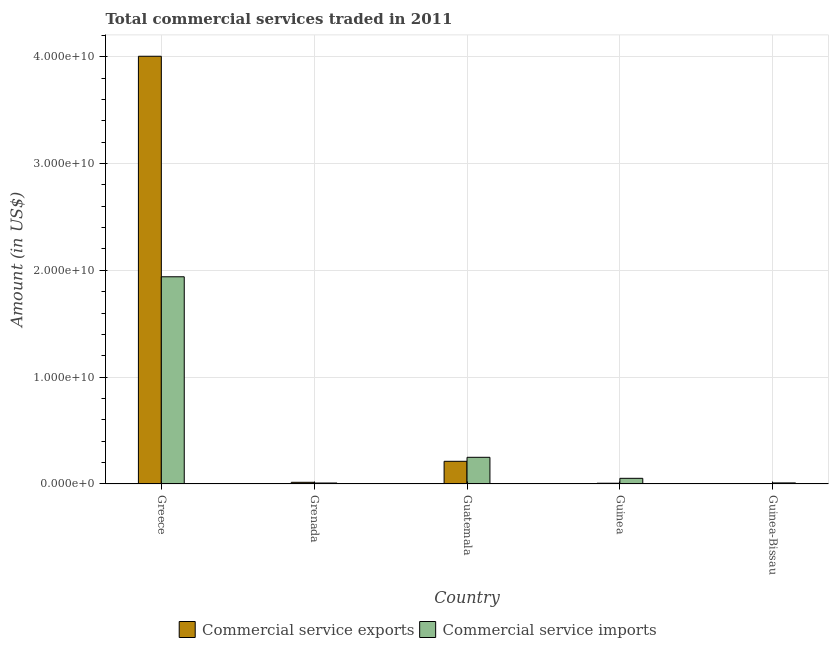Are the number of bars on each tick of the X-axis equal?
Give a very brief answer. Yes. How many bars are there on the 5th tick from the left?
Your answer should be compact. 2. What is the label of the 5th group of bars from the left?
Give a very brief answer. Guinea-Bissau. What is the amount of commercial service exports in Guinea?
Your response must be concise. 7.06e+07. Across all countries, what is the maximum amount of commercial service imports?
Provide a short and direct response. 1.94e+1. Across all countries, what is the minimum amount of commercial service exports?
Provide a short and direct response. 4.35e+07. In which country was the amount of commercial service exports minimum?
Give a very brief answer. Guinea-Bissau. What is the total amount of commercial service imports in the graph?
Offer a terse response. 2.26e+1. What is the difference between the amount of commercial service exports in Guatemala and that in Guinea-Bissau?
Provide a succinct answer. 2.08e+09. What is the difference between the amount of commercial service imports in Guinea-Bissau and the amount of commercial service exports in Greece?
Keep it short and to the point. -3.99e+1. What is the average amount of commercial service imports per country?
Offer a very short reply. 4.52e+09. What is the difference between the amount of commercial service exports and amount of commercial service imports in Guinea-Bissau?
Give a very brief answer. -5.61e+07. What is the ratio of the amount of commercial service imports in Greece to that in Grenada?
Offer a very short reply. 213.61. What is the difference between the highest and the second highest amount of commercial service imports?
Give a very brief answer. 1.69e+1. What is the difference between the highest and the lowest amount of commercial service imports?
Provide a succinct answer. 1.93e+1. What does the 1st bar from the left in Guinea represents?
Offer a terse response. Commercial service exports. What does the 2nd bar from the right in Guatemala represents?
Keep it short and to the point. Commercial service exports. How many countries are there in the graph?
Make the answer very short. 5. Does the graph contain grids?
Provide a succinct answer. Yes. How are the legend labels stacked?
Your answer should be compact. Horizontal. What is the title of the graph?
Your answer should be compact. Total commercial services traded in 2011. What is the label or title of the X-axis?
Offer a terse response. Country. What is the Amount (in US$) of Commercial service exports in Greece?
Your answer should be compact. 4.00e+1. What is the Amount (in US$) of Commercial service imports in Greece?
Offer a terse response. 1.94e+1. What is the Amount (in US$) in Commercial service exports in Grenada?
Provide a succinct answer. 1.57e+08. What is the Amount (in US$) of Commercial service imports in Grenada?
Your answer should be compact. 9.08e+07. What is the Amount (in US$) in Commercial service exports in Guatemala?
Ensure brevity in your answer.  2.12e+09. What is the Amount (in US$) of Commercial service imports in Guatemala?
Provide a short and direct response. 2.50e+09. What is the Amount (in US$) of Commercial service exports in Guinea?
Provide a succinct answer. 7.06e+07. What is the Amount (in US$) in Commercial service imports in Guinea?
Your response must be concise. 5.30e+08. What is the Amount (in US$) in Commercial service exports in Guinea-Bissau?
Make the answer very short. 4.35e+07. What is the Amount (in US$) in Commercial service imports in Guinea-Bissau?
Provide a short and direct response. 9.96e+07. Across all countries, what is the maximum Amount (in US$) in Commercial service exports?
Provide a succinct answer. 4.00e+1. Across all countries, what is the maximum Amount (in US$) in Commercial service imports?
Your response must be concise. 1.94e+1. Across all countries, what is the minimum Amount (in US$) of Commercial service exports?
Provide a short and direct response. 4.35e+07. Across all countries, what is the minimum Amount (in US$) of Commercial service imports?
Your response must be concise. 9.08e+07. What is the total Amount (in US$) in Commercial service exports in the graph?
Your answer should be very brief. 4.24e+1. What is the total Amount (in US$) in Commercial service imports in the graph?
Provide a short and direct response. 2.26e+1. What is the difference between the Amount (in US$) of Commercial service exports in Greece and that in Grenada?
Provide a short and direct response. 3.99e+1. What is the difference between the Amount (in US$) of Commercial service imports in Greece and that in Grenada?
Provide a succinct answer. 1.93e+1. What is the difference between the Amount (in US$) in Commercial service exports in Greece and that in Guatemala?
Make the answer very short. 3.79e+1. What is the difference between the Amount (in US$) in Commercial service imports in Greece and that in Guatemala?
Offer a terse response. 1.69e+1. What is the difference between the Amount (in US$) of Commercial service exports in Greece and that in Guinea?
Your response must be concise. 4.00e+1. What is the difference between the Amount (in US$) in Commercial service imports in Greece and that in Guinea?
Ensure brevity in your answer.  1.89e+1. What is the difference between the Amount (in US$) in Commercial service exports in Greece and that in Guinea-Bissau?
Your answer should be very brief. 4.00e+1. What is the difference between the Amount (in US$) in Commercial service imports in Greece and that in Guinea-Bissau?
Your answer should be compact. 1.93e+1. What is the difference between the Amount (in US$) of Commercial service exports in Grenada and that in Guatemala?
Give a very brief answer. -1.97e+09. What is the difference between the Amount (in US$) in Commercial service imports in Grenada and that in Guatemala?
Your answer should be compact. -2.41e+09. What is the difference between the Amount (in US$) in Commercial service exports in Grenada and that in Guinea?
Keep it short and to the point. 8.59e+07. What is the difference between the Amount (in US$) of Commercial service imports in Grenada and that in Guinea?
Make the answer very short. -4.39e+08. What is the difference between the Amount (in US$) in Commercial service exports in Grenada and that in Guinea-Bissau?
Your answer should be compact. 1.13e+08. What is the difference between the Amount (in US$) in Commercial service imports in Grenada and that in Guinea-Bissau?
Your answer should be very brief. -8.75e+06. What is the difference between the Amount (in US$) in Commercial service exports in Guatemala and that in Guinea?
Offer a terse response. 2.05e+09. What is the difference between the Amount (in US$) of Commercial service imports in Guatemala and that in Guinea?
Your answer should be compact. 1.97e+09. What is the difference between the Amount (in US$) in Commercial service exports in Guatemala and that in Guinea-Bissau?
Keep it short and to the point. 2.08e+09. What is the difference between the Amount (in US$) of Commercial service imports in Guatemala and that in Guinea-Bissau?
Offer a terse response. 2.40e+09. What is the difference between the Amount (in US$) of Commercial service exports in Guinea and that in Guinea-Bissau?
Offer a very short reply. 2.71e+07. What is the difference between the Amount (in US$) of Commercial service imports in Guinea and that in Guinea-Bissau?
Provide a succinct answer. 4.30e+08. What is the difference between the Amount (in US$) in Commercial service exports in Greece and the Amount (in US$) in Commercial service imports in Grenada?
Your response must be concise. 4.00e+1. What is the difference between the Amount (in US$) in Commercial service exports in Greece and the Amount (in US$) in Commercial service imports in Guatemala?
Your answer should be very brief. 3.75e+1. What is the difference between the Amount (in US$) of Commercial service exports in Greece and the Amount (in US$) of Commercial service imports in Guinea?
Provide a succinct answer. 3.95e+1. What is the difference between the Amount (in US$) in Commercial service exports in Greece and the Amount (in US$) in Commercial service imports in Guinea-Bissau?
Your response must be concise. 3.99e+1. What is the difference between the Amount (in US$) of Commercial service exports in Grenada and the Amount (in US$) of Commercial service imports in Guatemala?
Provide a succinct answer. -2.34e+09. What is the difference between the Amount (in US$) of Commercial service exports in Grenada and the Amount (in US$) of Commercial service imports in Guinea?
Give a very brief answer. -3.73e+08. What is the difference between the Amount (in US$) in Commercial service exports in Grenada and the Amount (in US$) in Commercial service imports in Guinea-Bissau?
Provide a short and direct response. 5.70e+07. What is the difference between the Amount (in US$) of Commercial service exports in Guatemala and the Amount (in US$) of Commercial service imports in Guinea?
Offer a very short reply. 1.59e+09. What is the difference between the Amount (in US$) of Commercial service exports in Guatemala and the Amount (in US$) of Commercial service imports in Guinea-Bissau?
Your answer should be compact. 2.02e+09. What is the difference between the Amount (in US$) of Commercial service exports in Guinea and the Amount (in US$) of Commercial service imports in Guinea-Bissau?
Provide a short and direct response. -2.90e+07. What is the average Amount (in US$) of Commercial service exports per country?
Provide a short and direct response. 8.49e+09. What is the average Amount (in US$) in Commercial service imports per country?
Offer a terse response. 4.52e+09. What is the difference between the Amount (in US$) of Commercial service exports and Amount (in US$) of Commercial service imports in Greece?
Provide a succinct answer. 2.06e+1. What is the difference between the Amount (in US$) in Commercial service exports and Amount (in US$) in Commercial service imports in Grenada?
Give a very brief answer. 6.57e+07. What is the difference between the Amount (in US$) in Commercial service exports and Amount (in US$) in Commercial service imports in Guatemala?
Offer a terse response. -3.75e+08. What is the difference between the Amount (in US$) in Commercial service exports and Amount (in US$) in Commercial service imports in Guinea?
Keep it short and to the point. -4.59e+08. What is the difference between the Amount (in US$) of Commercial service exports and Amount (in US$) of Commercial service imports in Guinea-Bissau?
Provide a succinct answer. -5.61e+07. What is the ratio of the Amount (in US$) in Commercial service exports in Greece to that in Grenada?
Your answer should be compact. 255.82. What is the ratio of the Amount (in US$) in Commercial service imports in Greece to that in Grenada?
Provide a short and direct response. 213.61. What is the ratio of the Amount (in US$) of Commercial service exports in Greece to that in Guatemala?
Provide a succinct answer. 18.86. What is the ratio of the Amount (in US$) of Commercial service imports in Greece to that in Guatemala?
Give a very brief answer. 7.77. What is the ratio of the Amount (in US$) of Commercial service exports in Greece to that in Guinea?
Offer a very short reply. 567.28. What is the ratio of the Amount (in US$) in Commercial service imports in Greece to that in Guinea?
Offer a very short reply. 36.63. What is the ratio of the Amount (in US$) in Commercial service exports in Greece to that in Guinea-Bissau?
Your response must be concise. 920.95. What is the ratio of the Amount (in US$) in Commercial service imports in Greece to that in Guinea-Bissau?
Your answer should be very brief. 194.83. What is the ratio of the Amount (in US$) in Commercial service exports in Grenada to that in Guatemala?
Give a very brief answer. 0.07. What is the ratio of the Amount (in US$) of Commercial service imports in Grenada to that in Guatemala?
Offer a very short reply. 0.04. What is the ratio of the Amount (in US$) in Commercial service exports in Grenada to that in Guinea?
Your answer should be very brief. 2.22. What is the ratio of the Amount (in US$) in Commercial service imports in Grenada to that in Guinea?
Make the answer very short. 0.17. What is the ratio of the Amount (in US$) in Commercial service exports in Grenada to that in Guinea-Bissau?
Keep it short and to the point. 3.6. What is the ratio of the Amount (in US$) of Commercial service imports in Grenada to that in Guinea-Bissau?
Keep it short and to the point. 0.91. What is the ratio of the Amount (in US$) of Commercial service exports in Guatemala to that in Guinea?
Ensure brevity in your answer.  30.08. What is the ratio of the Amount (in US$) in Commercial service imports in Guatemala to that in Guinea?
Offer a very short reply. 4.72. What is the ratio of the Amount (in US$) in Commercial service exports in Guatemala to that in Guinea-Bissau?
Your answer should be compact. 48.83. What is the ratio of the Amount (in US$) in Commercial service imports in Guatemala to that in Guinea-Bissau?
Give a very brief answer. 25.09. What is the ratio of the Amount (in US$) in Commercial service exports in Guinea to that in Guinea-Bissau?
Your answer should be compact. 1.62. What is the ratio of the Amount (in US$) of Commercial service imports in Guinea to that in Guinea-Bissau?
Your response must be concise. 5.32. What is the difference between the highest and the second highest Amount (in US$) in Commercial service exports?
Offer a terse response. 3.79e+1. What is the difference between the highest and the second highest Amount (in US$) of Commercial service imports?
Your answer should be very brief. 1.69e+1. What is the difference between the highest and the lowest Amount (in US$) in Commercial service exports?
Your answer should be very brief. 4.00e+1. What is the difference between the highest and the lowest Amount (in US$) of Commercial service imports?
Make the answer very short. 1.93e+1. 